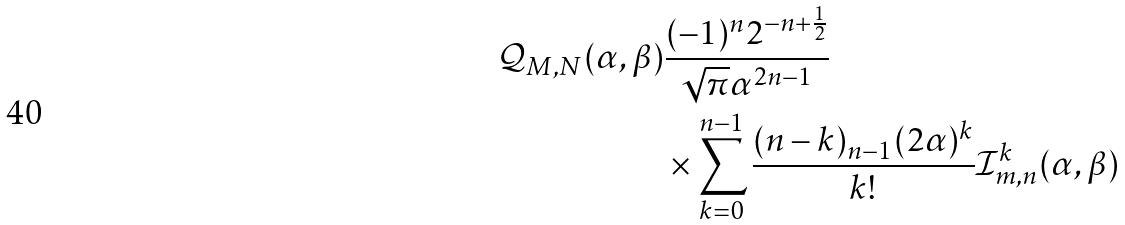<formula> <loc_0><loc_0><loc_500><loc_500>\mathcal { Q } _ { M , N } ( \alpha , \beta ) & \frac { ( - 1 ) ^ { n } 2 ^ { - n + \frac { 1 } { 2 } } } { \sqrt { \pi } \alpha ^ { 2 n - 1 } } \\ & \times \sum _ { k = 0 } ^ { n - 1 } \frac { ( n - k ) _ { n - 1 } ( 2 \alpha ) ^ { k } } { k ! } \mathcal { I } _ { m , n } ^ { k } ( \alpha , \beta )</formula> 